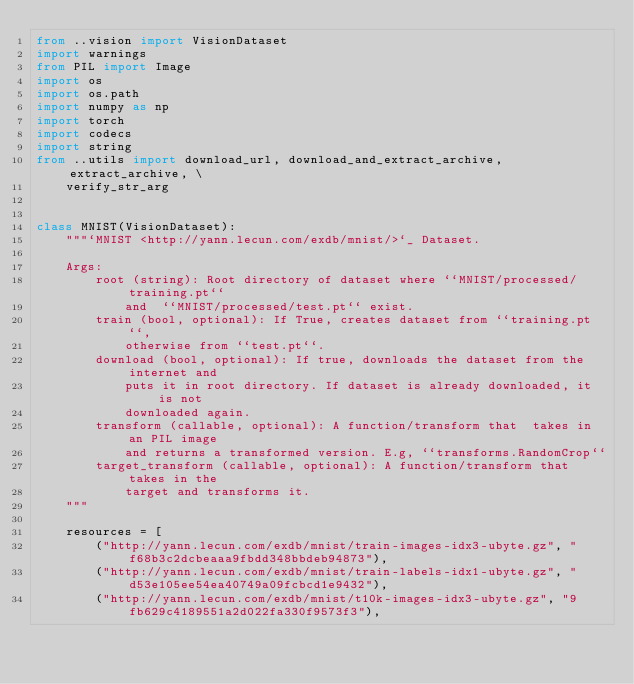Convert code to text. <code><loc_0><loc_0><loc_500><loc_500><_Python_>from ..vision import VisionDataset
import warnings
from PIL import Image
import os
import os.path
import numpy as np
import torch
import codecs
import string
from ..utils import download_url, download_and_extract_archive, extract_archive, \
    verify_str_arg


class MNIST(VisionDataset):
    """`MNIST <http://yann.lecun.com/exdb/mnist/>`_ Dataset.

    Args:
        root (string): Root directory of dataset where ``MNIST/processed/training.pt``
            and  ``MNIST/processed/test.pt`` exist.
        train (bool, optional): If True, creates dataset from ``training.pt``,
            otherwise from ``test.pt``.
        download (bool, optional): If true, downloads the dataset from the internet and
            puts it in root directory. If dataset is already downloaded, it is not
            downloaded again.
        transform (callable, optional): A function/transform that  takes in an PIL image
            and returns a transformed version. E.g, ``transforms.RandomCrop``
        target_transform (callable, optional): A function/transform that takes in the
            target and transforms it.
    """

    resources = [
        ("http://yann.lecun.com/exdb/mnist/train-images-idx3-ubyte.gz", "f68b3c2dcbeaaa9fbdd348bbdeb94873"),
        ("http://yann.lecun.com/exdb/mnist/train-labels-idx1-ubyte.gz", "d53e105ee54ea40749a09fcbcd1e9432"),
        ("http://yann.lecun.com/exdb/mnist/t10k-images-idx3-ubyte.gz", "9fb629c4189551a2d022fa330f9573f3"),</code> 